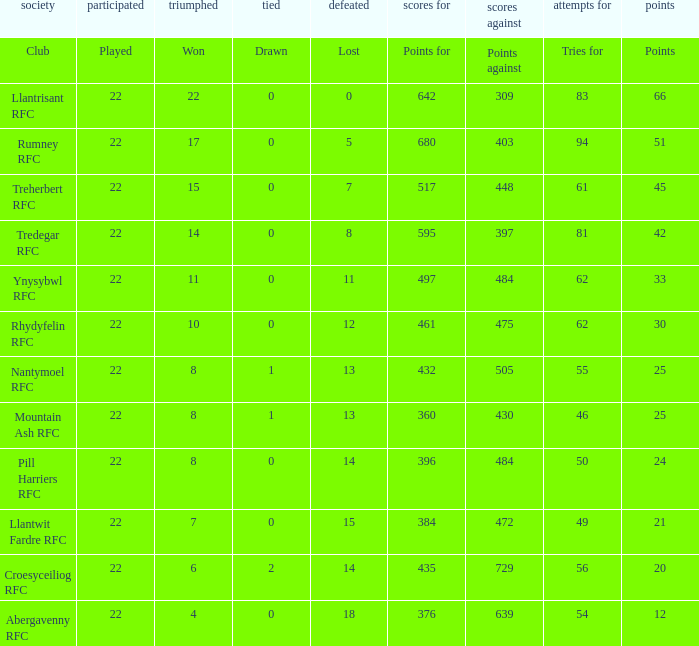How many points for were scored by the team that won exactly 22? 642.0. 